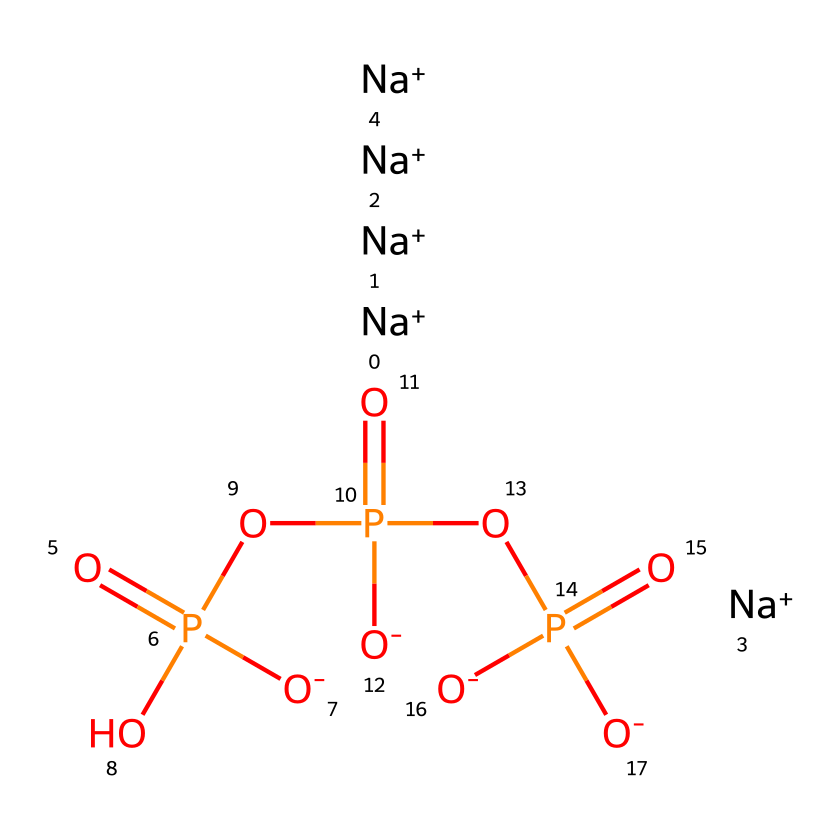What is the total number of sodium ions present in this molecule? This molecule has five sodium ions indicated by the notation [Na+]. Each sodium ion is represented separately, and counting them gives a total of five.
Answer: five How many phosphate groups are present in this molecule? The structure contains three phosphate groups. Each phosphate is represented by the O=P notation, and there are three distinct instances of this representation throughout the SMILES structure.
Answer: three What is the overall charge of the molecule? The sodium ions are positively charged, while the phosphate groups have negative charges. Netting off the five positive charges from three negative charges gives an overall charge of +2.
Answer: positive two Which part of this chemical contributes to water softening? The phosphate groups (O=P) are responsible for water softening as they bind with calcium and magnesium ions in hard water, facilitating easier lathering of detergents.
Answer: phosphate groups What is the primary function of phosphates in detergents? The primary function of phosphates in detergents is to enhance cleaning efficiency by binding to metal ions, thus preventing them from interfering with the surfactants in detergents.
Answer: enhance cleaning efficiency Identify the type of chemical bonding primarily present in this molecule. The molecule exhibits ionic bonding between the sodium ions and the phosphate groups, as well as covalent bonding within the phosphate groups themselves.
Answer: ionic and covalent Which elements are bonded to the phosphorus atoms in the phosphate groups? The phosphorus atoms in the phosphate groups are bonded to oxygen atoms, which are part of the overall molecular structure represented by the oxygen atoms following the P in the SMILES.
Answer: oxygen atoms 